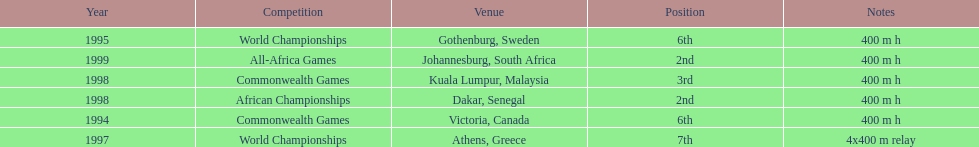How long was the relay at the 1997 world championships that ken harden ran 4x400 m relay. 